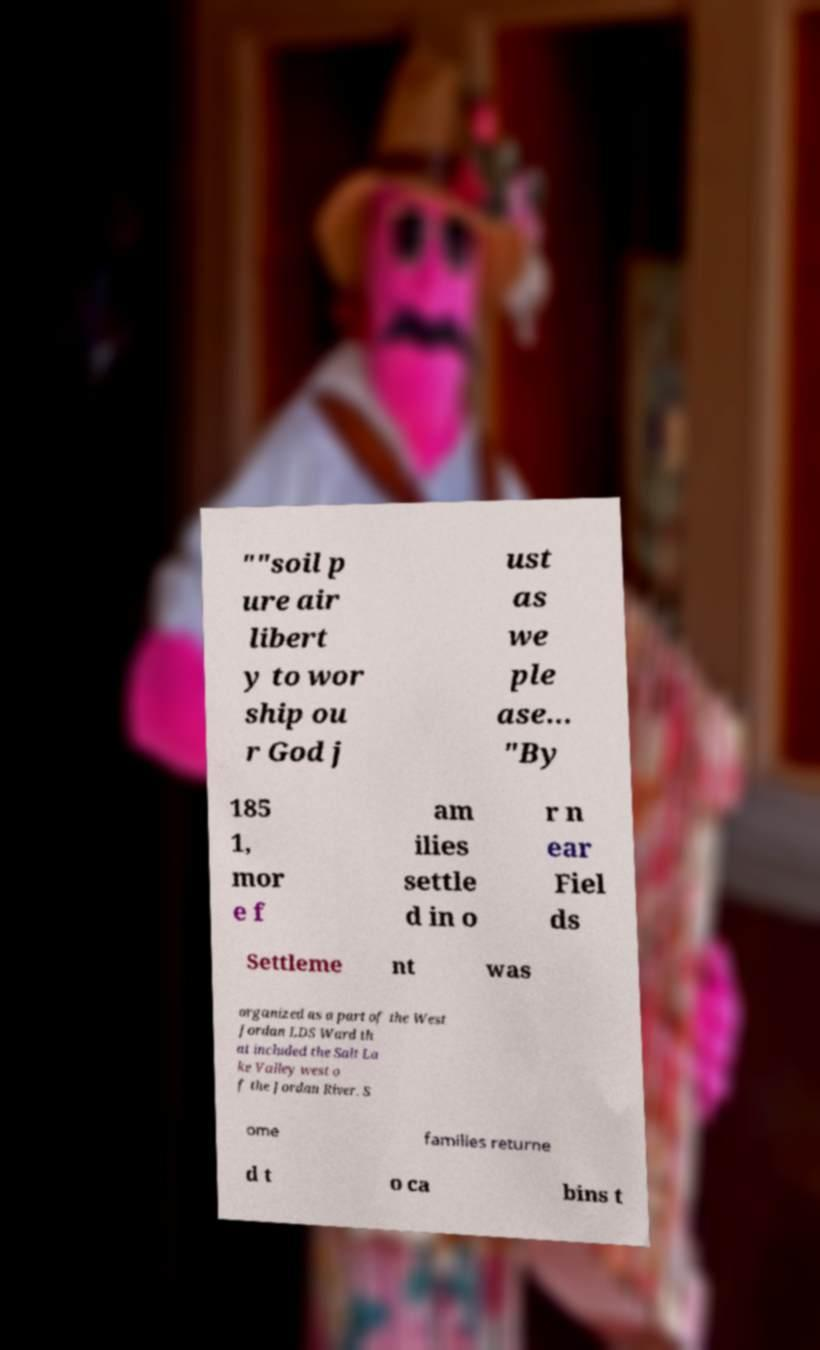Can you read and provide the text displayed in the image?This photo seems to have some interesting text. Can you extract and type it out for me? ""soil p ure air libert y to wor ship ou r God j ust as we ple ase… "By 185 1, mor e f am ilies settle d in o r n ear Fiel ds Settleme nt was organized as a part of the West Jordan LDS Ward th at included the Salt La ke Valley west o f the Jordan River. S ome families returne d t o ca bins t 